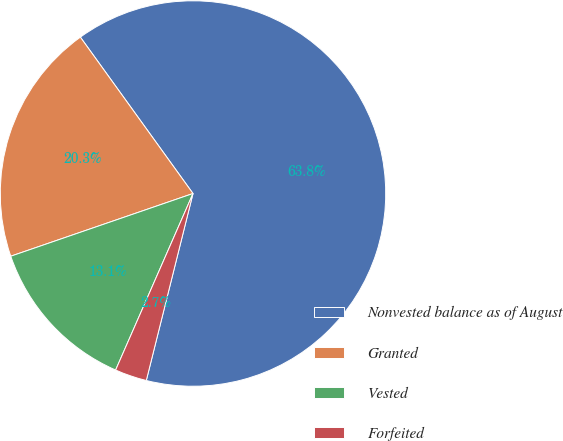<chart> <loc_0><loc_0><loc_500><loc_500><pie_chart><fcel>Nonvested balance as of August<fcel>Granted<fcel>Vested<fcel>Forfeited<nl><fcel>63.83%<fcel>20.34%<fcel>13.15%<fcel>2.68%<nl></chart> 